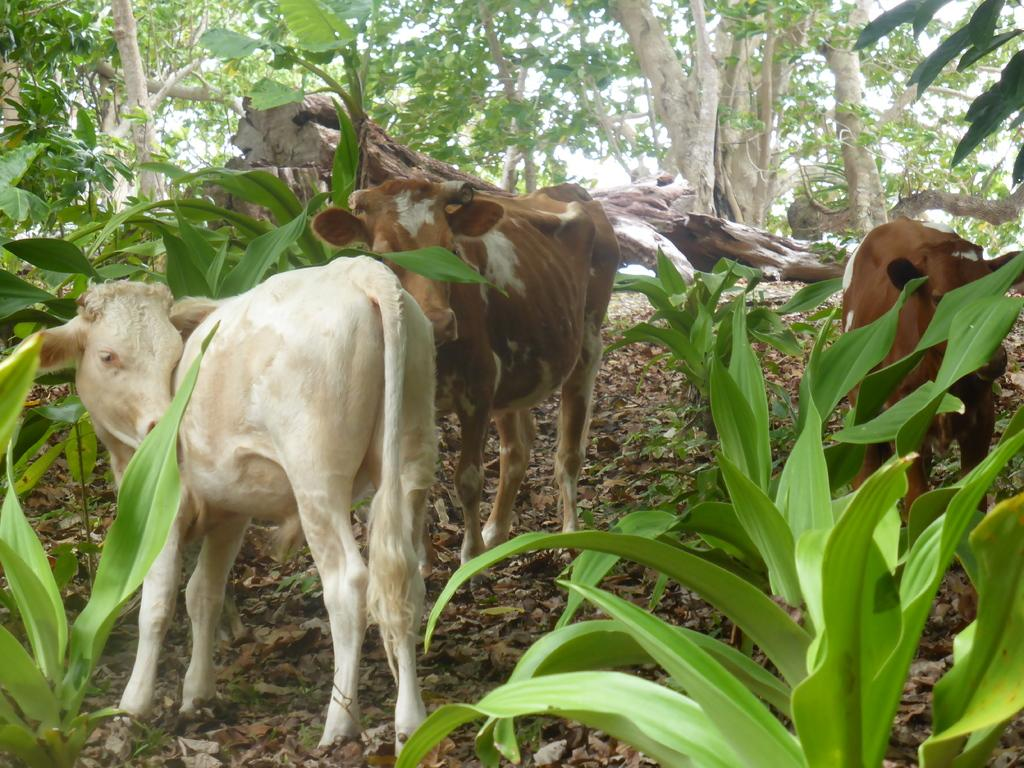What type of living organisms can be seen on the ground in the image? There are animals on the ground in the image. What other natural elements are present in the image? There are plants and trees in the image. Can you describe the tree trunk in the image? Yes, there is a tree trunk in the image. What is visible in the background of the image? The sky is visible in the background of the image. What time is displayed on the clock in the image? There is no clock present in the image. What type of vacation is being taken in the image? There is no indication of a vacation in the image. 